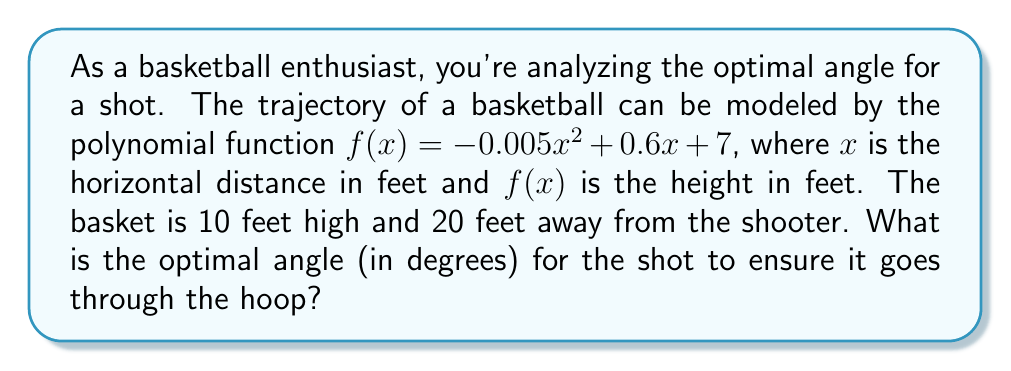Help me with this question. To find the optimal angle for the shot, we need to follow these steps:

1) First, we need to find the slope of the trajectory at the point where it reaches the basket. This slope will give us the tangent of the angle we're looking for.

2) The basket is 20 feet away horizontally, so we need to find the derivative of $f(x)$ at $x = 20$.

3) The derivative of $f(x)$ is:
   $f'(x) = -0.01x + 0.6$

4) At $x = 20$:
   $f'(20) = -0.01(20) + 0.6 = -0.2 + 0.6 = 0.4$

5) This means the slope of the trajectory at the basket is 0.4.

6) The tangent of the angle is equal to this slope. So:
   $\tan(\theta) = 0.4$

7) To find the angle, we need to take the inverse tangent (arctangent):
   $\theta = \arctan(0.4)$

8) Converting this to degrees:
   $\theta = \arctan(0.4) \cdot \frac{180}{\pi} \approx 21.80^\circ$

Therefore, the optimal angle for the shot is approximately 21.80 degrees.
Answer: $21.80^\circ$ 